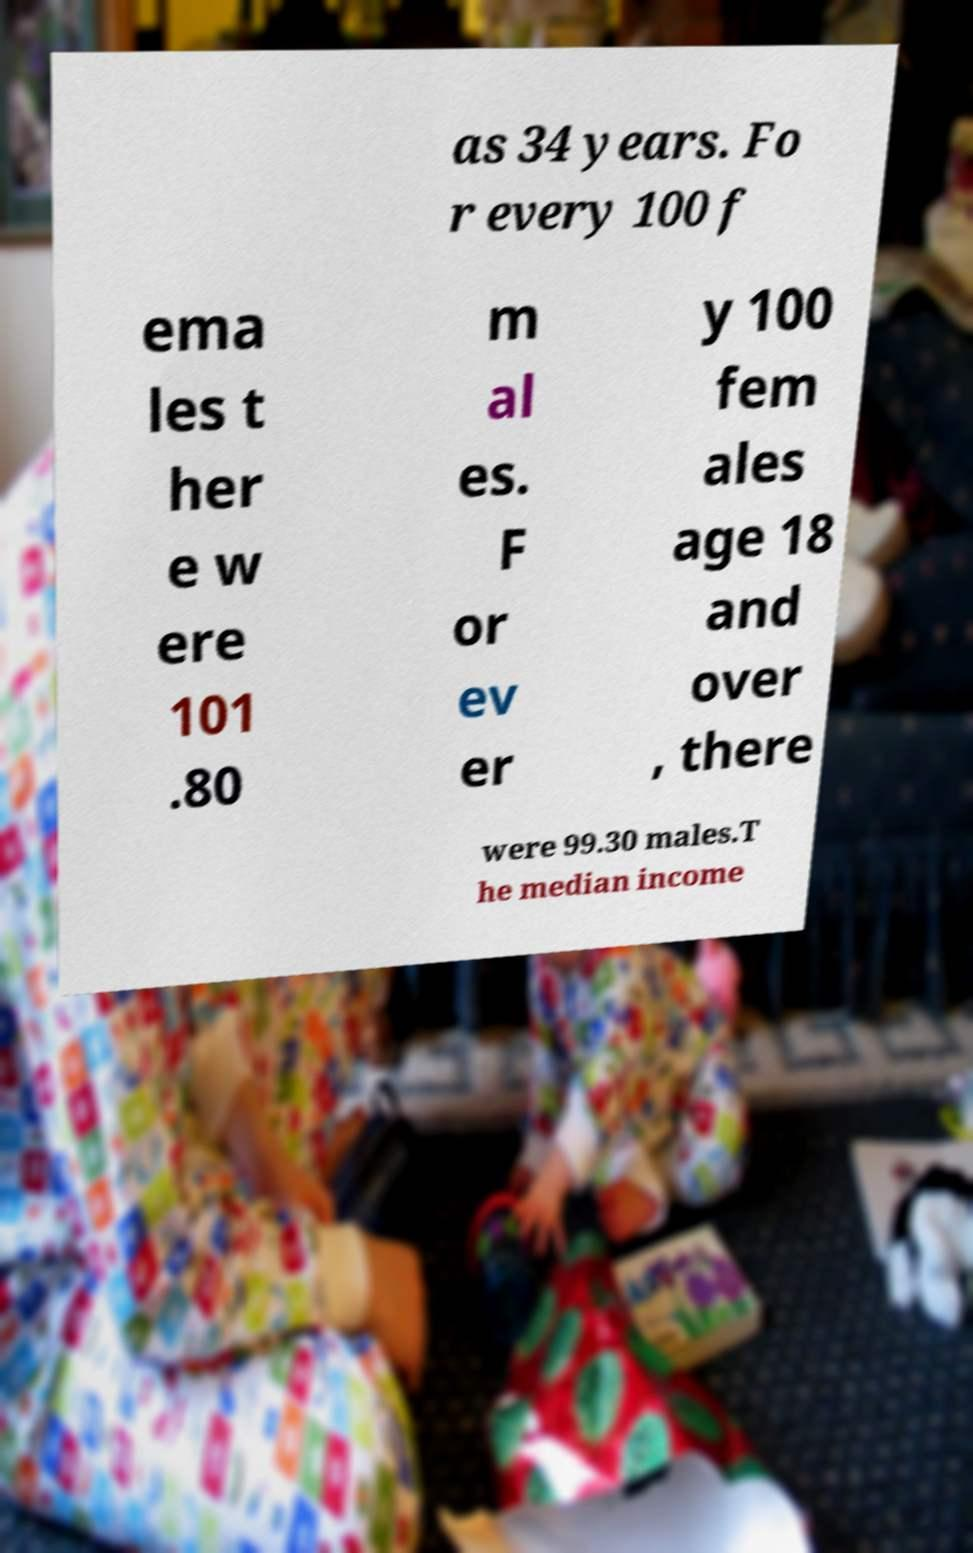Can you accurately transcribe the text from the provided image for me? as 34 years. Fo r every 100 f ema les t her e w ere 101 .80 m al es. F or ev er y 100 fem ales age 18 and over , there were 99.30 males.T he median income 